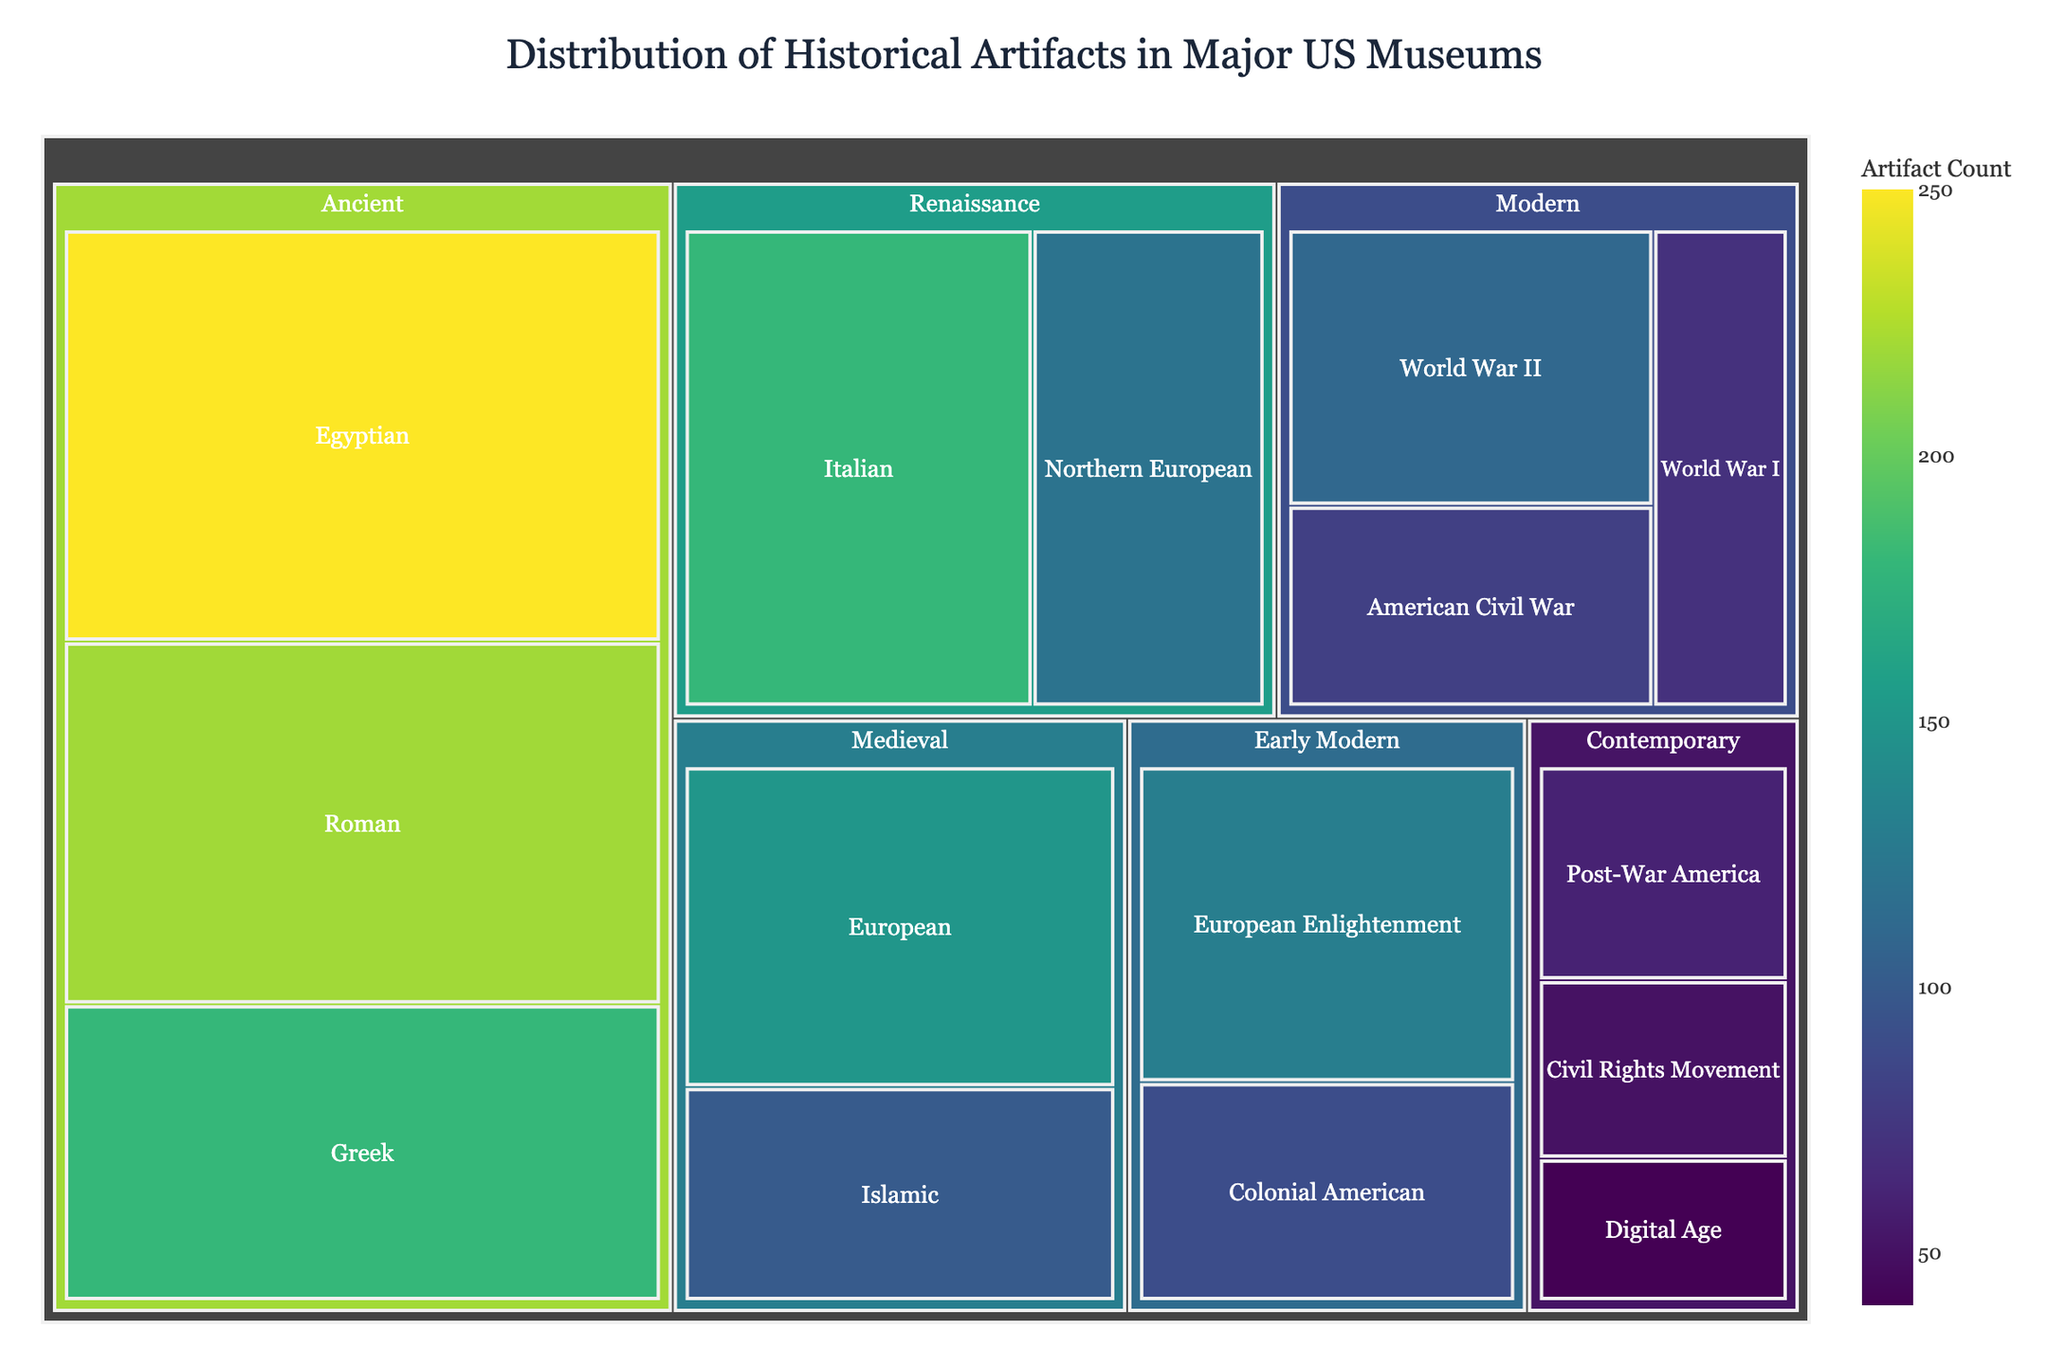How many total artifacts are in the "Ancient" category? To find the total number of artifacts in the "Ancient" category, add the values for the Egyptian, Greek, and Roman subcategories: 250 (Egyptian) + 180 (Greek) + 220 (Roman) = 650.
Answer: 650 Which subcategory has the highest number of artifacts? Look for the subcategory with the largest value. The Egyptian subcategory has the highest value with 250 artifacts.
Answer: Egyptian How many more artifacts are in the "Renaissance" category compared to the "Modern" category? Calculate the total artifacts in "Renaissance" (Italian: 180 + Northern European: 120 = 300) and "Modern" (American Civil War: 80 + World War I: 70 + World War II: 110 = 260). The difference is 300 - 260 = 40.
Answer: 40 What is the total number of artifacts in the "Contemporary" category? Add the values of all subcategories in the "Contemporary" category: Post-War America (60) + Civil Rights Movement (50) + Digital Age (40) = 150.
Answer: 150 Which historical period has the least representation in terms of artifact count? Compare the total counts for each period; the "Early Modern" period has the least with 220 artifacts.
Answer: Early Modern In which category does the "World War II" subcategory fall? Look at the treemap and find where "World War II" is located. It is within the "Modern" category.
Answer: Modern How many artifacts are there in the "Islamic" subcategory in the "Medieval" category? Identify the value linked to the "Islamic" subcategory under "Medieval." It has 100 artifacts.
Answer: 100 Which subcategory has fewer artifacts, "Colonial American" or "European Enlightenment"? Compare the artifact counts for "Colonial American" (90) and "European Enlightenment" (130). "Colonial American" has fewer artifacts.
Answer: Colonial American What is the difference in artifact count between the "Greek" subcategory and the "Italian" subcategory? Subtract the number of artifacts in the "Greek" subcategory (180) from the number of artifacts in the "Italian" subcategory (180). The difference is 0.
Answer: 0 